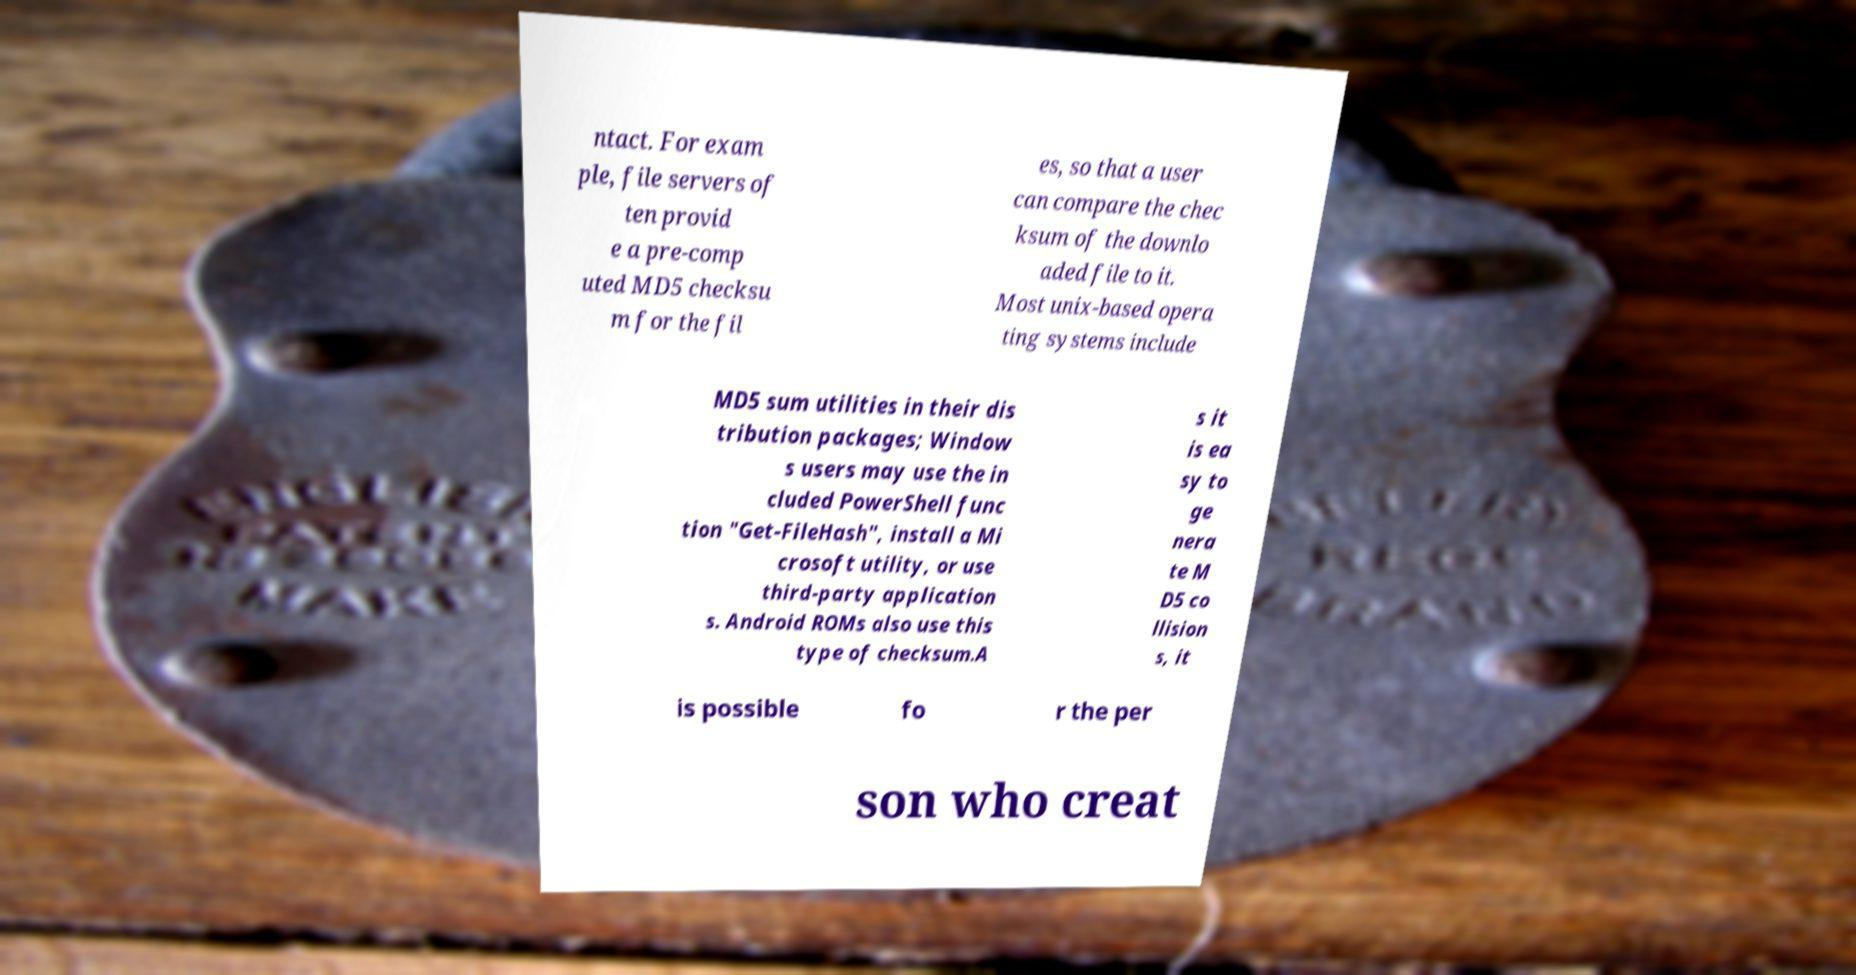Can you accurately transcribe the text from the provided image for me? ntact. For exam ple, file servers of ten provid e a pre-comp uted MD5 checksu m for the fil es, so that a user can compare the chec ksum of the downlo aded file to it. Most unix-based opera ting systems include MD5 sum utilities in their dis tribution packages; Window s users may use the in cluded PowerShell func tion "Get-FileHash", install a Mi crosoft utility, or use third-party application s. Android ROMs also use this type of checksum.A s it is ea sy to ge nera te M D5 co llision s, it is possible fo r the per son who creat 